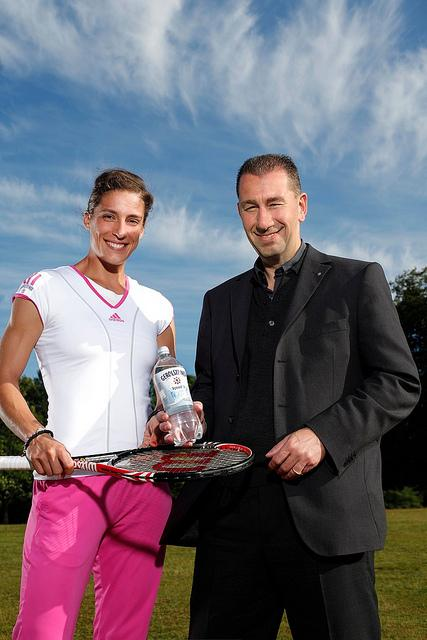What corporation made the shirt the woman is wearing? Please explain your reasoning. adidas. It has the triangular logo in the middle of her shirt 